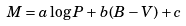Convert formula to latex. <formula><loc_0><loc_0><loc_500><loc_500>M = a \log P + b ( B - V ) + c</formula> 